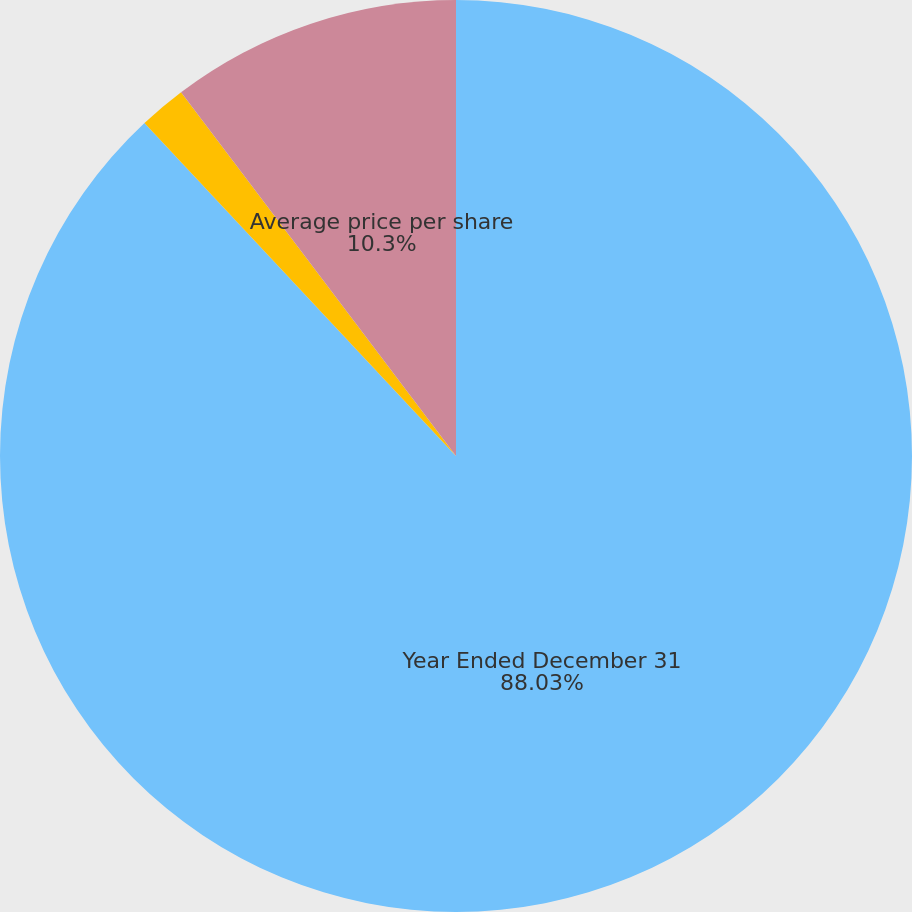Convert chart to OTSL. <chart><loc_0><loc_0><loc_500><loc_500><pie_chart><fcel>Year Ended December 31<fcel>Number of shares repurchased<fcel>Average price per share<nl><fcel>88.03%<fcel>1.67%<fcel>10.3%<nl></chart> 